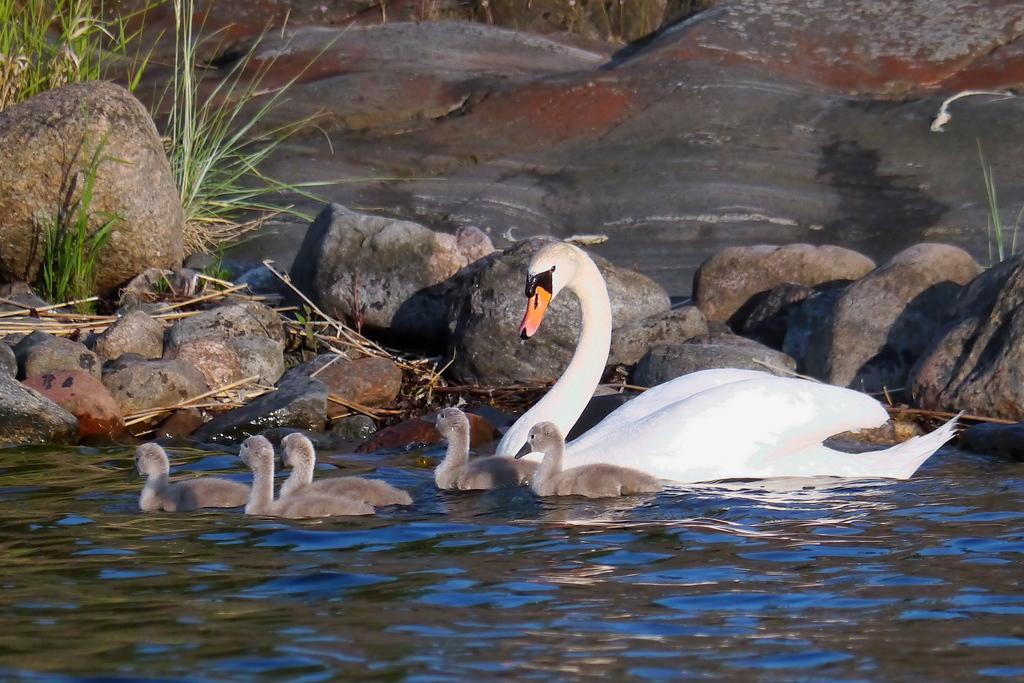What animals can be seen in the water in the image? There are swans in the water in the image. What can be seen in the background of the image? There are rocks and plants in the background of the image. What type of oil can be seen floating on the water in the image? There is no oil visible in the image; it features swans in the water with rocks and plants in the background. 